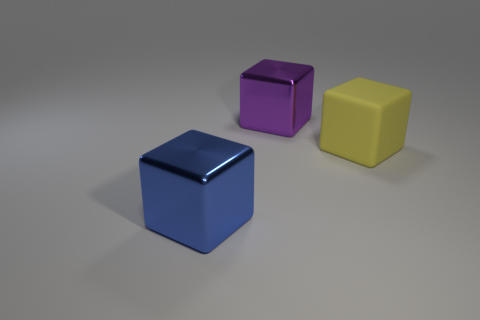The thing that is left of the purple shiny block is what color? blue 